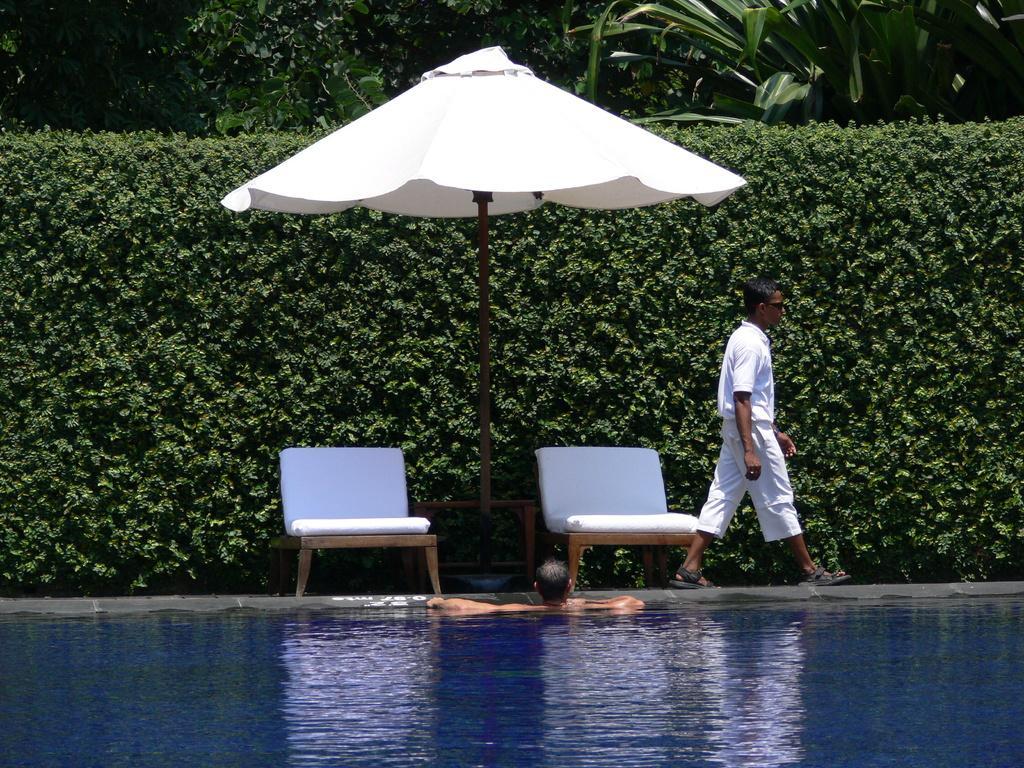In one or two sentences, can you explain what this image depicts? On the right there is a man walking on the platform and a person in the water. In the background there are trees,plants,tent and two chairs. 